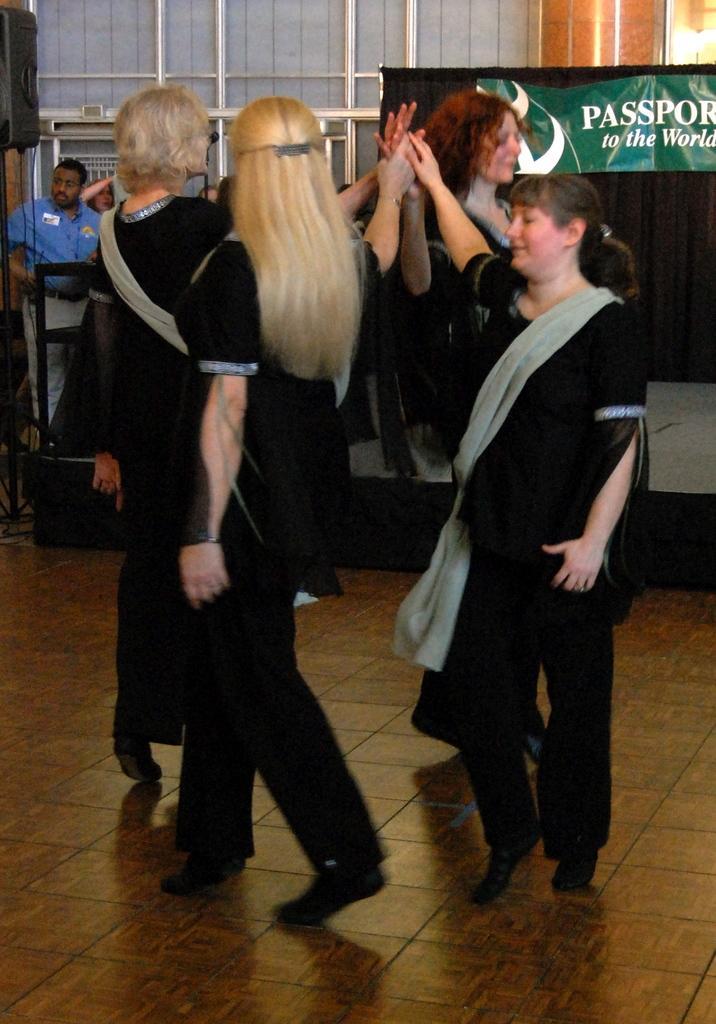Describe this image in one or two sentences. In the front of the image we can see people. In the background of the image we can see people, stage, curtains, banner, speaker, pillar, rods and things.   